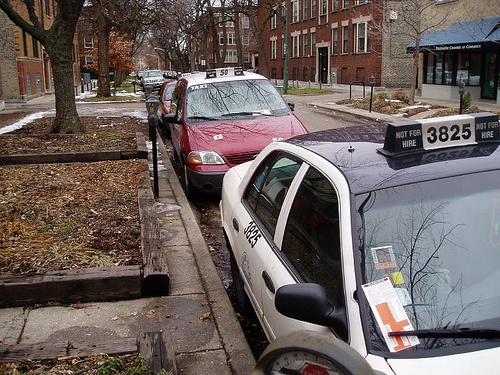Describe the objects in this image and their specific colors. I can see car in black, darkgray, lightgray, and gray tones, car in black, darkgray, lightpink, and gray tones, parking meter in black and gray tones, car in black, darkgray, gray, and maroon tones, and parking meter in black, gray, and darkgray tones in this image. 